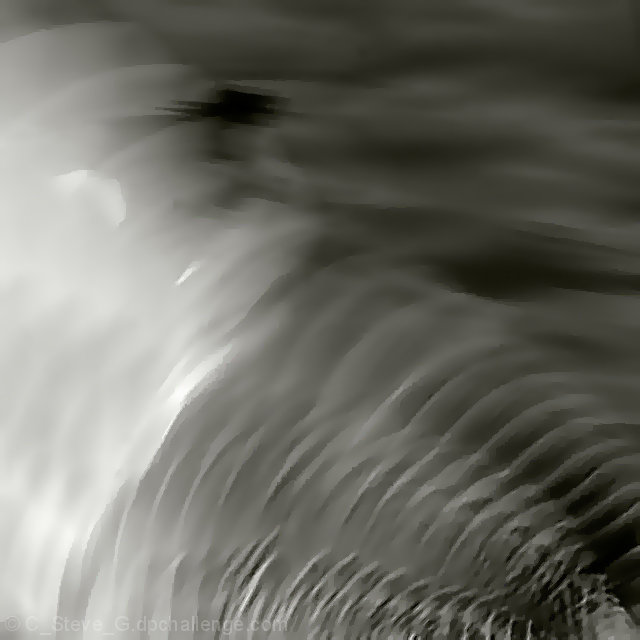Is this image in color or black and white, and what effect does that have on the mood? The image is presented in monochrome, utilizing shades of gray to create its impact. The absence of color focuses the viewer's attention on the textural elements and the interplay of light and shadow, which imbues the scene with a timeless and somewhat introspective mood. 